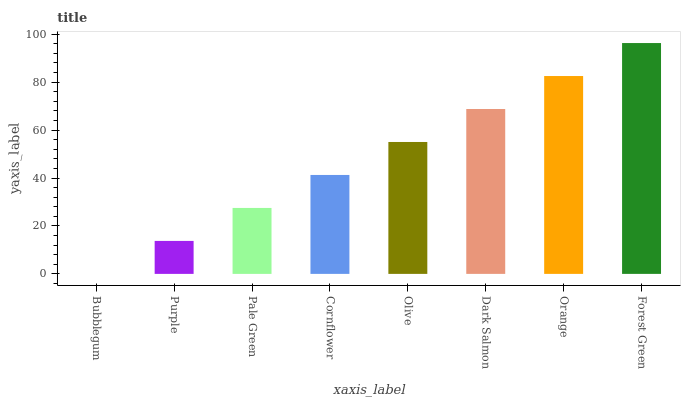Is Bubblegum the minimum?
Answer yes or no. Yes. Is Forest Green the maximum?
Answer yes or no. Yes. Is Purple the minimum?
Answer yes or no. No. Is Purple the maximum?
Answer yes or no. No. Is Purple greater than Bubblegum?
Answer yes or no. Yes. Is Bubblegum less than Purple?
Answer yes or no. Yes. Is Bubblegum greater than Purple?
Answer yes or no. No. Is Purple less than Bubblegum?
Answer yes or no. No. Is Olive the high median?
Answer yes or no. Yes. Is Cornflower the low median?
Answer yes or no. Yes. Is Purple the high median?
Answer yes or no. No. Is Pale Green the low median?
Answer yes or no. No. 